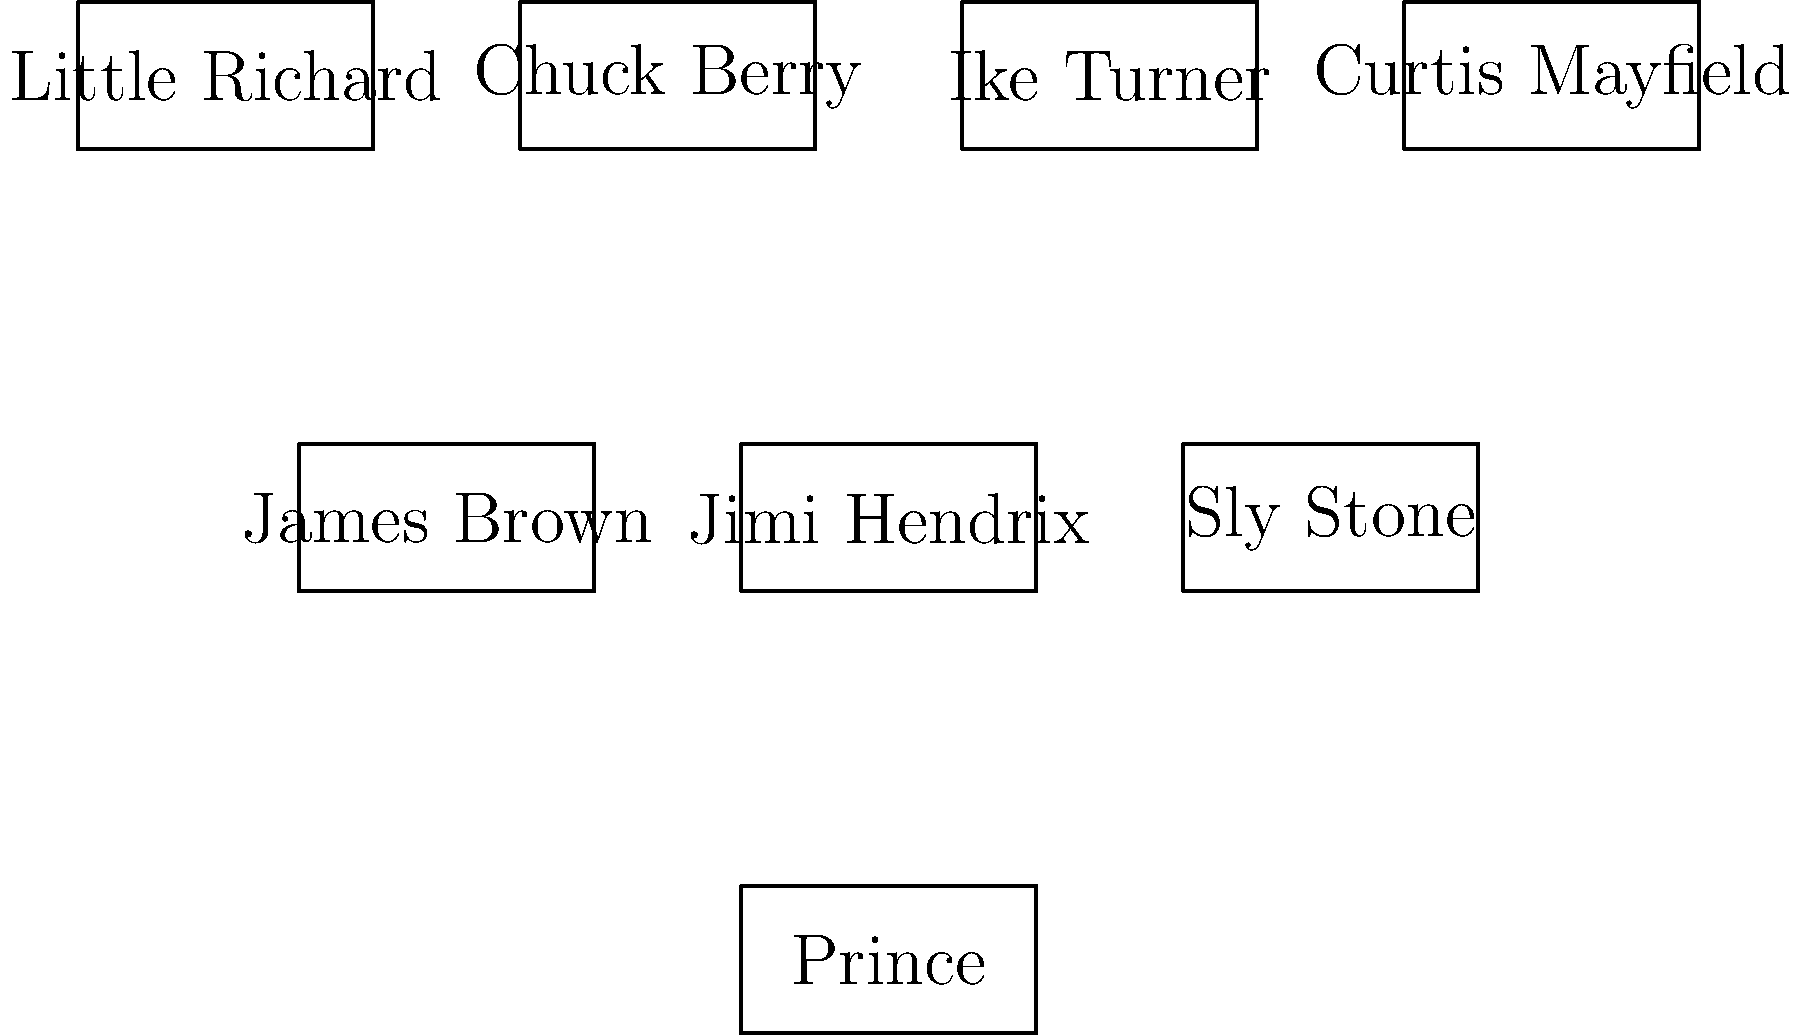Based on the family tree diagram of Prince's musical influences, which artist directly influenced both James Brown and Sly Stone, who in turn influenced Prince? To answer this question, we need to analyze the family tree diagram of Prince's musical influences:

1. First, we identify Prince at the bottom of the diagram.
2. We see three direct influences on Prince: James Brown, Jimi Hendrix, and Sly Stone.
3. Moving up the diagram, we observe the influences on these artists:
   - James Brown is influenced by Little Richard and Chuck Berry
   - Sly Stone is influenced by Ike Turner and Curtis Mayfield
4. To find an artist who influenced both James Brown and Sly Stone, we need to look for a common connection.
5. Examining the diagram, we see that Little Richard has an arrow pointing to James Brown, but not to Sly Stone.
6. Chuck Berry also only has an arrow pointing to James Brown.
7. Ike Turner and Curtis Mayfield only have arrows pointing to Sly Stone.

Therefore, based on the information provided in the diagram, there is no artist who directly influenced both James Brown and Sly Stone.
Answer: None 